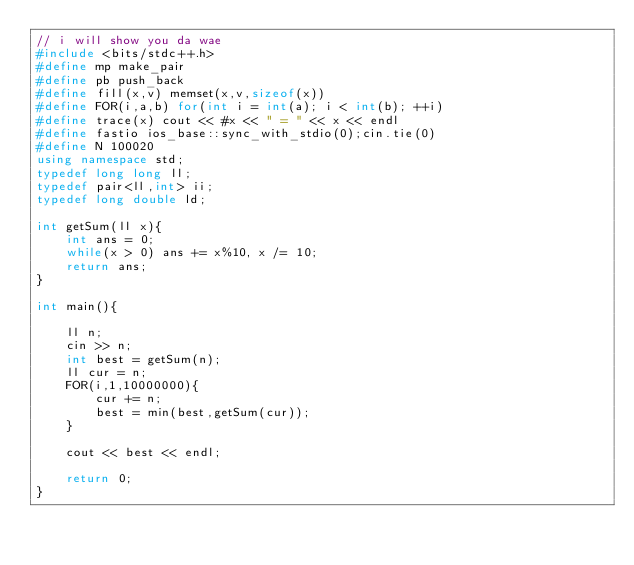Convert code to text. <code><loc_0><loc_0><loc_500><loc_500><_C++_>// i will show you da wae
#include <bits/stdc++.h>
#define mp make_pair
#define pb push_back
#define fill(x,v) memset(x,v,sizeof(x))
#define FOR(i,a,b) for(int i = int(a); i < int(b); ++i)
#define trace(x) cout << #x << " = " << x << endl
#define fastio ios_base::sync_with_stdio(0);cin.tie(0)
#define N 100020
using namespace std;
typedef long long ll;
typedef pair<ll,int> ii;
typedef long double ld;

int getSum(ll x){
	int ans = 0;
	while(x > 0) ans += x%10, x /= 10;
	return ans;
}

int main(){
	
	ll n;
	cin >> n;
	int best = getSum(n);
	ll cur = n;
	FOR(i,1,10000000){
		cur += n;
		best = min(best,getSum(cur));
	}
	
	cout << best << endl;
	
	return 0;
}</code> 